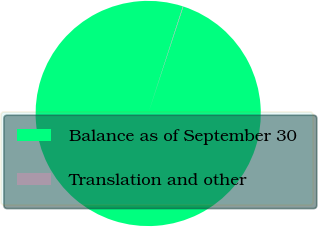Convert chart to OTSL. <chart><loc_0><loc_0><loc_500><loc_500><pie_chart><fcel>Balance as of September 30<fcel>Translation and other<nl><fcel>99.94%<fcel>0.06%<nl></chart> 